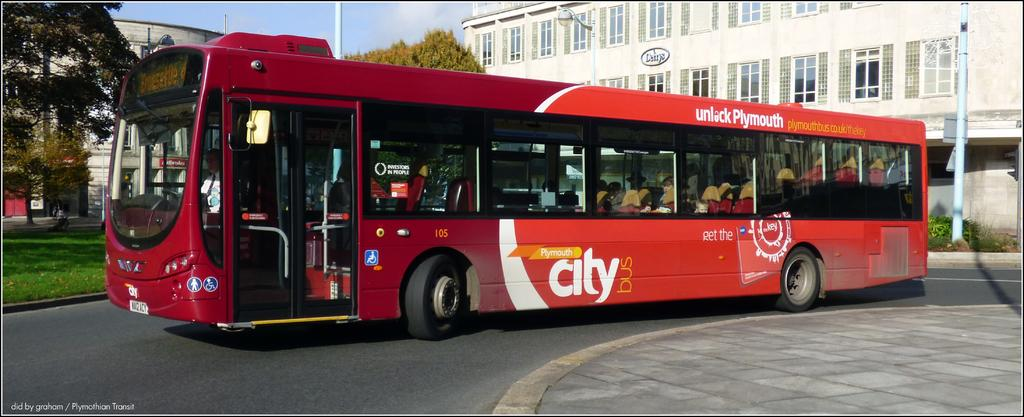What is the main subject of the image? There is a bus in the image. What other objects or features can be seen in the image? There is a tree and a building in the background of the image. What can be seen in the sky? There are clouds visible in the sky. Where is the flame located in the image? There is no flame present in the image. What type of bait is being used by the person in the image? There is no person or bait present in the image. 